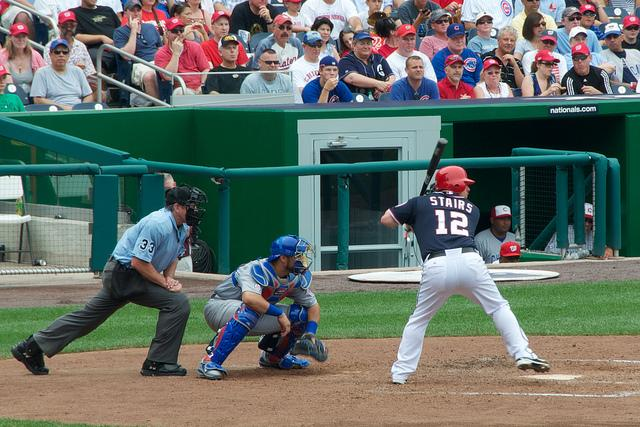What team does the catcher play for? Please explain your reasoning. cubs. The team is the cubs. 